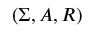<formula> <loc_0><loc_0><loc_500><loc_500>( \Sigma , A , R )</formula> 